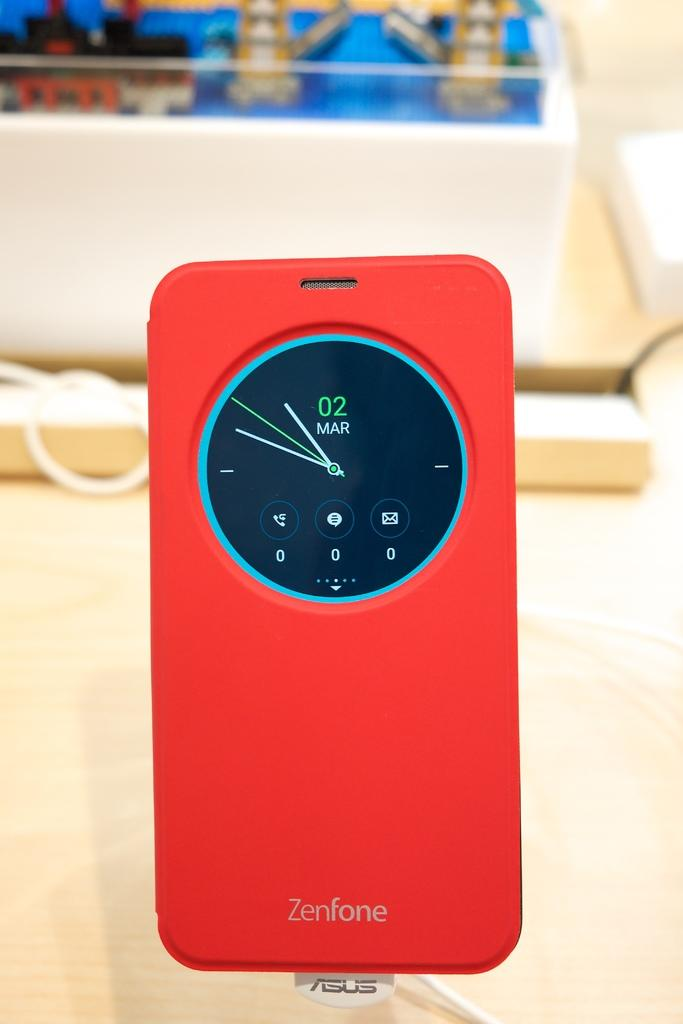<image>
Summarize the visual content of the image. A red Zenfone sits on display with the date March 02 on the screen 